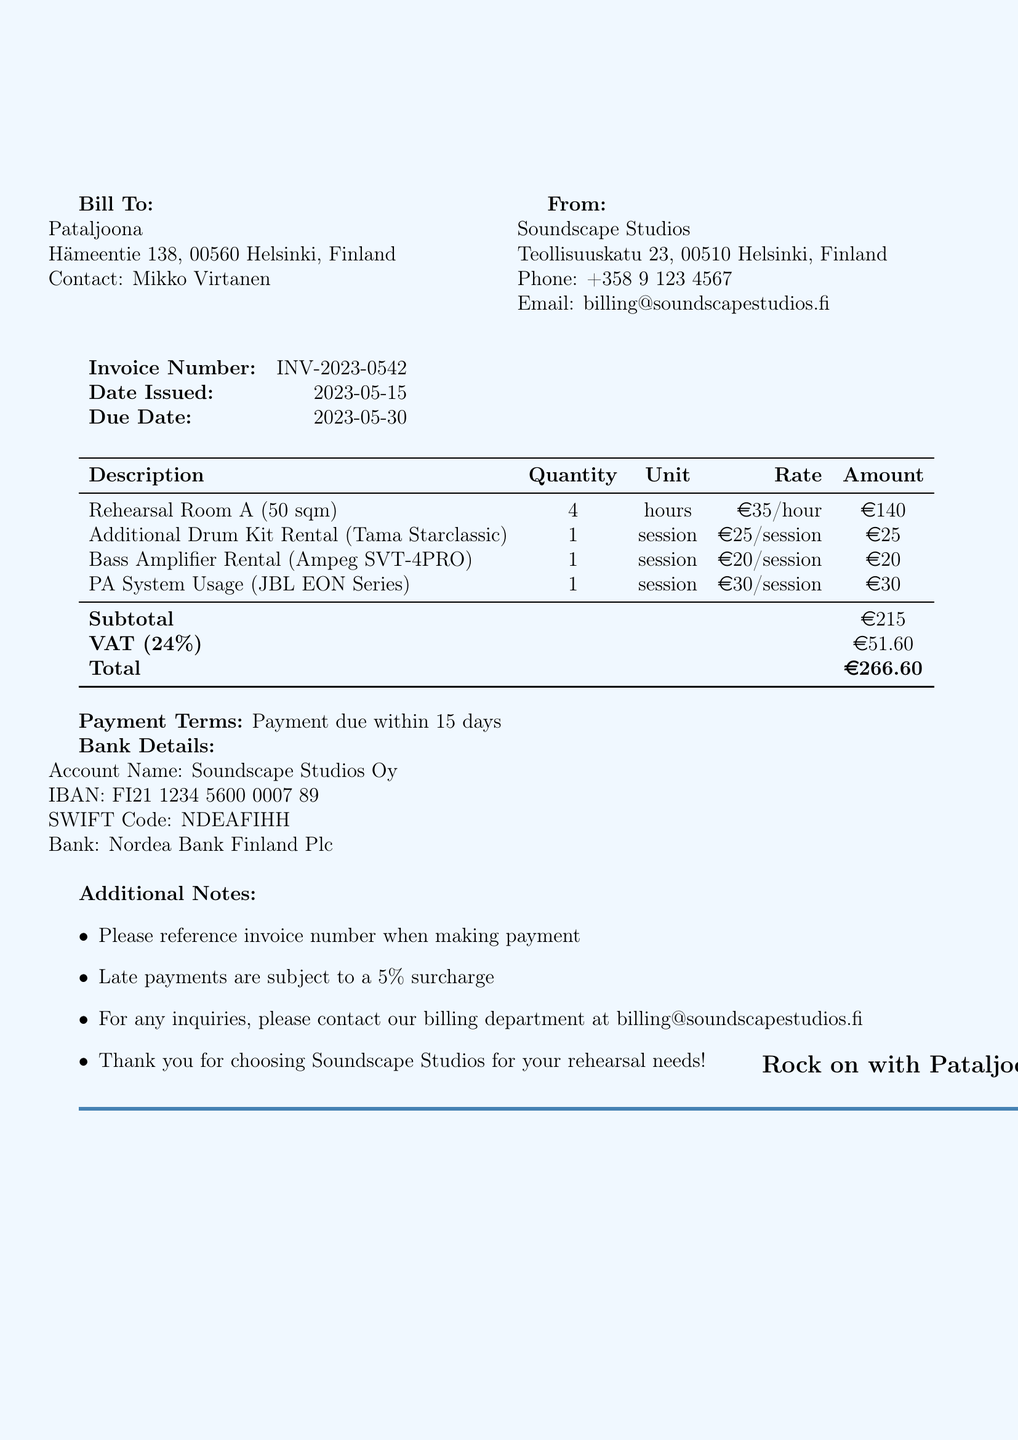What is the invoice number? The invoice number is a unique identifier for the transaction, listed as INV-2023-0542.
Answer: INV-2023-0542 Who is the bill to? The bill-to section specifies the name of the entity being billed, which is Pataljoona.
Answer: Pataljoona What is the subtotal amount? The subtotal is the sum of all items before tax, which is clearly stated as 215 euros.
Answer: 215 How many hours was the rehearsal room rented? The quantity of rehearsal room hours rented is listed in the item description, which is 4 hours.
Answer: 4 What is the due date for the payment? The due date for payment indicates when the bill must be settled, which is specified as 2023-05-30.
Answer: 2023-05-30 What is the total amount due? The total amount due is the final sum including taxes, presented as 266.60 euros.
Answer: 266.60 Which equipment is included in the additional rental fees? The document lists the rented additional equipment: a drum kit, a bass amplifier, and a PA system.
Answer: Drum kit, bass amplifier, PA system What happens to late payments? The document specifies that late payments are subject to a surcharge, indicating a consequence for delayed payment.
Answer: 5% surcharge What are the payment terms? The terms specify how soon the payment should be made and are given as "Payment due within 15 days."
Answer: Payment due within 15 days 